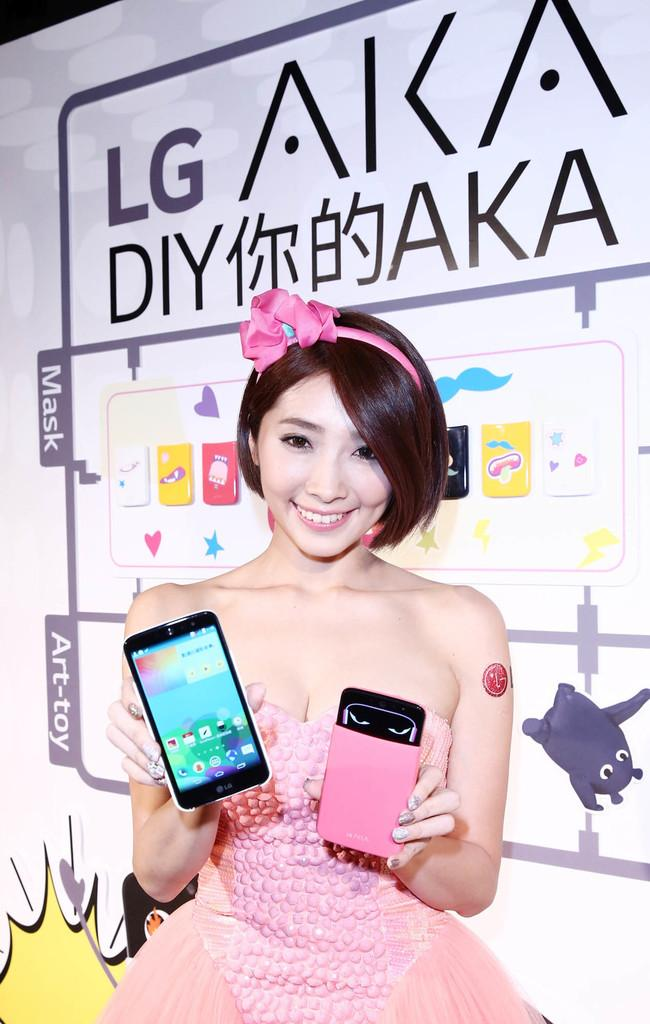Who is present in the image? There is a woman in the image. What is the woman holding in her hands? The woman is holding mobile phones in her hands. What is the woman's facial expression? The woman is smiling. What is the woman wearing on her head? The woman is wearing a hair band. What can be seen in the background of the image? There is an LG poster in the background of the image. Where is the jail located in the image? There is no jail present in the image. How many mobile phones are in the woman's pocket in the image? The woman is not holding mobile phones in her pocket; she is holding them in her hands. 